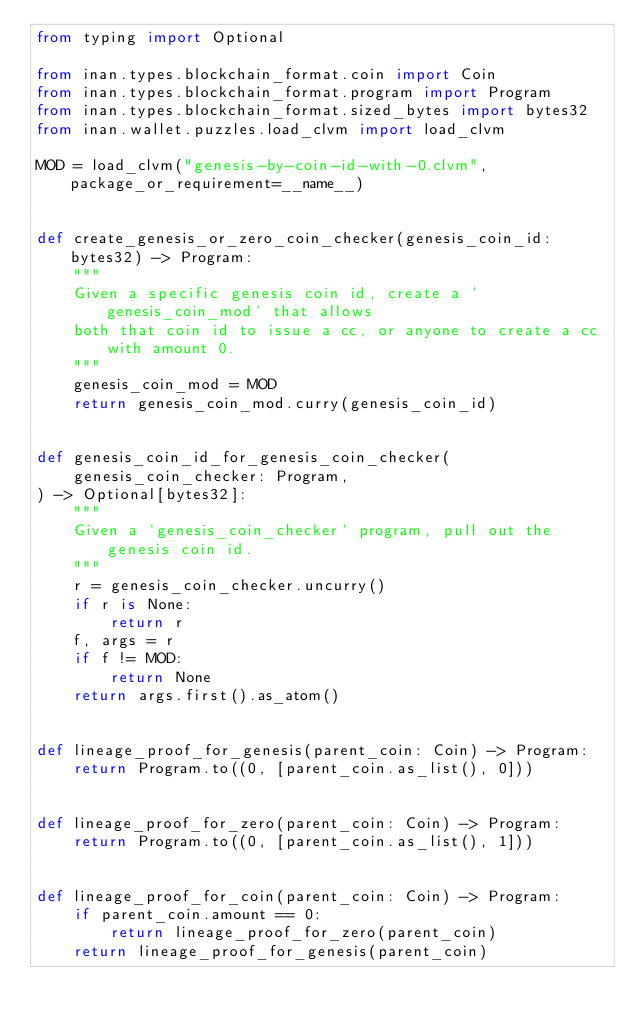<code> <loc_0><loc_0><loc_500><loc_500><_Python_>from typing import Optional

from inan.types.blockchain_format.coin import Coin
from inan.types.blockchain_format.program import Program
from inan.types.blockchain_format.sized_bytes import bytes32
from inan.wallet.puzzles.load_clvm import load_clvm

MOD = load_clvm("genesis-by-coin-id-with-0.clvm", package_or_requirement=__name__)


def create_genesis_or_zero_coin_checker(genesis_coin_id: bytes32) -> Program:
    """
    Given a specific genesis coin id, create a `genesis_coin_mod` that allows
    both that coin id to issue a cc, or anyone to create a cc with amount 0.
    """
    genesis_coin_mod = MOD
    return genesis_coin_mod.curry(genesis_coin_id)


def genesis_coin_id_for_genesis_coin_checker(
    genesis_coin_checker: Program,
) -> Optional[bytes32]:
    """
    Given a `genesis_coin_checker` program, pull out the genesis coin id.
    """
    r = genesis_coin_checker.uncurry()
    if r is None:
        return r
    f, args = r
    if f != MOD:
        return None
    return args.first().as_atom()


def lineage_proof_for_genesis(parent_coin: Coin) -> Program:
    return Program.to((0, [parent_coin.as_list(), 0]))


def lineage_proof_for_zero(parent_coin: Coin) -> Program:
    return Program.to((0, [parent_coin.as_list(), 1]))


def lineage_proof_for_coin(parent_coin: Coin) -> Program:
    if parent_coin.amount == 0:
        return lineage_proof_for_zero(parent_coin)
    return lineage_proof_for_genesis(parent_coin)
</code> 